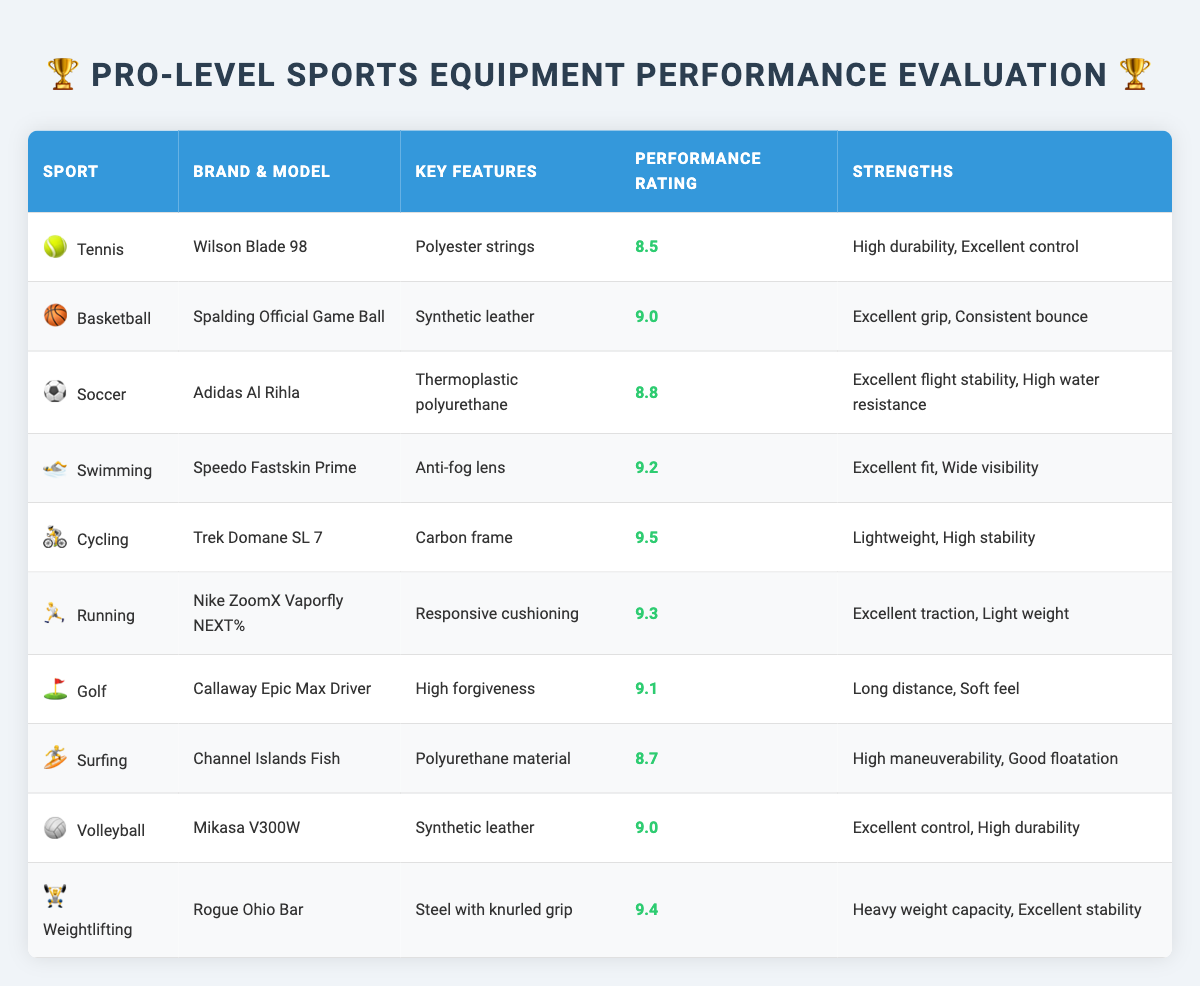What is the performance rating of the Nike ZoomX Vaporfly NEXT% running shoes? The performance rating is listed in the table under the Running section for the Nike ZoomX Vaporfly NEXT% shoes, which shows a value of 9.3.
Answer: 9.3 Which sport utilizes the Callaway Epic Max Driver? In the table, it states that the Callaway Epic Max is used in the sport of Golf.
Answer: Golf Is the Wilson Blade 98 racket rated higher than 9.0? To determine this, I look at the performance rating for Wilson Blade 98 listed as 8.5, which is lower than 9.0.
Answer: No What are the key features of the Speedo Fastskin Prime goggles? The key features are recorded in the table under the Swimming category, which includes anti-fog lens type.
Answer: Anti-fog lens Calculate the average performance rating of the tennis, soccer, and volleyball equipment. The performance ratings are 8.5 for Tennis, 8.8 for Soccer, and 9.0 for Volleyball. Sum them: (8.5 + 8.8 + 9.0 = 26.3). There are three sports, so the average is 26.3 / 3 = 8.767.
Answer: 8.767 Which sports equipment brand has the highest performance rating? Reviewing the performance ratings, the Trek Domane SL 7 from Cycling has the highest rating at 9.5, which is greater than all others listed.
Answer: Trek Is the Adidas Al Rihla soccer ball noted for having a soft kicking feel? The record for the Adidas Al Rihla soccer ball in the table states that its kicking feel is soft. Thus, it is indeed noted for this feature.
Answer: Yes What material is used for the Mikasa V300W volleyball? The Mikasa V300W table identifies its material as synthetic leather, which is reflected in its description under the Volleyball category.
Answer: Synthetic leather Which sports equipment has the highest durability rating? The equipment labeled for Swim's Speedo Fastskin Prime and Volleyball's Mikasa V300W both have an ‘Excellent’ durability notation. However, the weightlifting Rogue Ohio Bar is rated as ‘Excellent’ while the others denote ‘High.’ Since they all state excellent or high, it would be accurate to claim both classifications possess commendable durability ratings.
Answer: Both have excellent durability ratings 